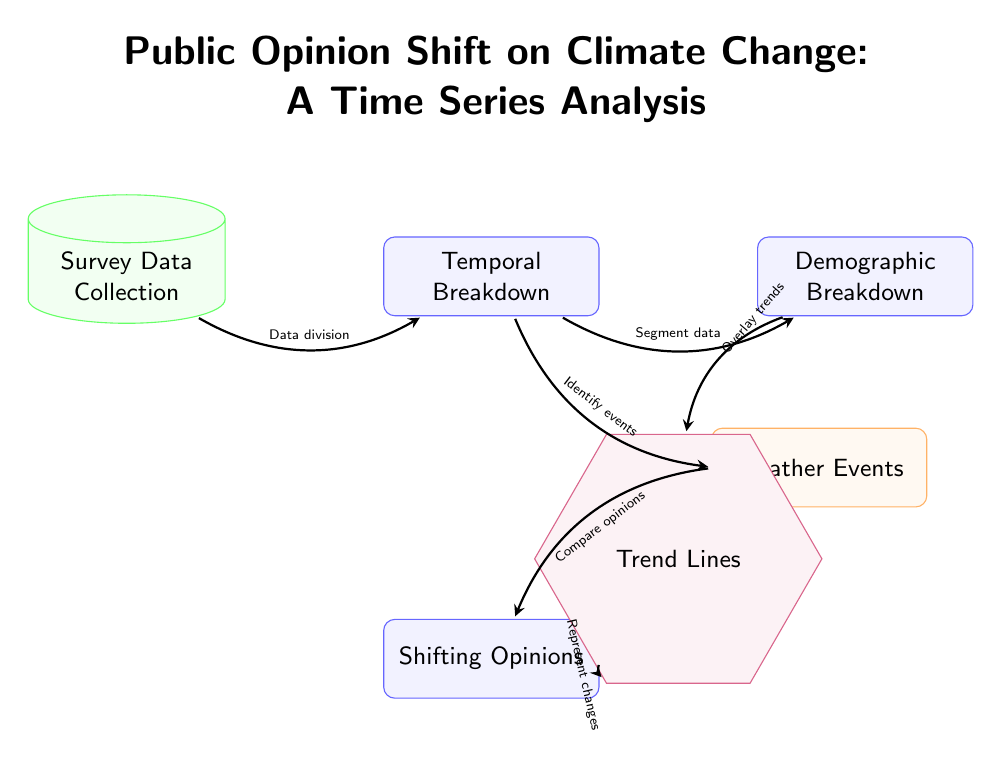What is the first step in the diagram? The first step involves collecting survey data, represented by the node labeled "Survey Data Collection." This node is the starting point of the flow in the diagram.
Answer: Survey Data Collection How many main process nodes are in the diagram? The diagram has three main process nodes: "Temporal Breakdown," "Shifting Opinions," and "Demographic Breakdown." By counting these nodes, we identify the main processes involved.
Answer: Three What type of data is represented by the "Survey Data Collection" node? The "Survey Data Collection" node represents the initial collection of survey data that serves as the basis for analyzing public opinion. It is categorized as data in the terminology used within the diagram.
Answer: Data What do the arrows indicate in this diagram? The arrows indicate the direction of the flow between the nodes, showing how data moves from the collection phase through various processes to arrive at the final visualization of trends. This is a typical feature in flow diagrams to depict relationships and pathways.
Answer: Direction of flow What follows the "Weather Events" node in the process? The "Shifting Opinions" node follows the "Weather Events" node, indicating that once the events are identified, the next step is to compare how opinions have changed in response to those events.
Answer: Shifting Opinions How is the demographic data utilized in the diagram? The demographic data is overlaid on the trend lines, as indicated by the arrow from the "Demographic Breakdown" node to the "Trend Lines" node, suggesting that demographic factors provide additional context to the trends observed.
Answer: Overlay trends What action is taken after "Temporal Breakdown"? After "Temporal Breakdown," the action is to identify events as shown by the arrow leading to the "Weather Events" node. This indicates that the timeline of survey data will help pinpoint significant weather events relevant to public opinion shifts.
Answer: Identify events What visual representation is included at the bottom of the diagram? The bottom of the diagram includes the "Trend Lines" node, which visually represents the changes in public opinion over time in the context of the collected data and identified events.
Answer: Trend Lines 